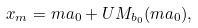Convert formula to latex. <formula><loc_0><loc_0><loc_500><loc_500>x _ { m } = m a _ { 0 } + U M _ { b _ { 0 } } ( m a _ { 0 } ) ,</formula> 